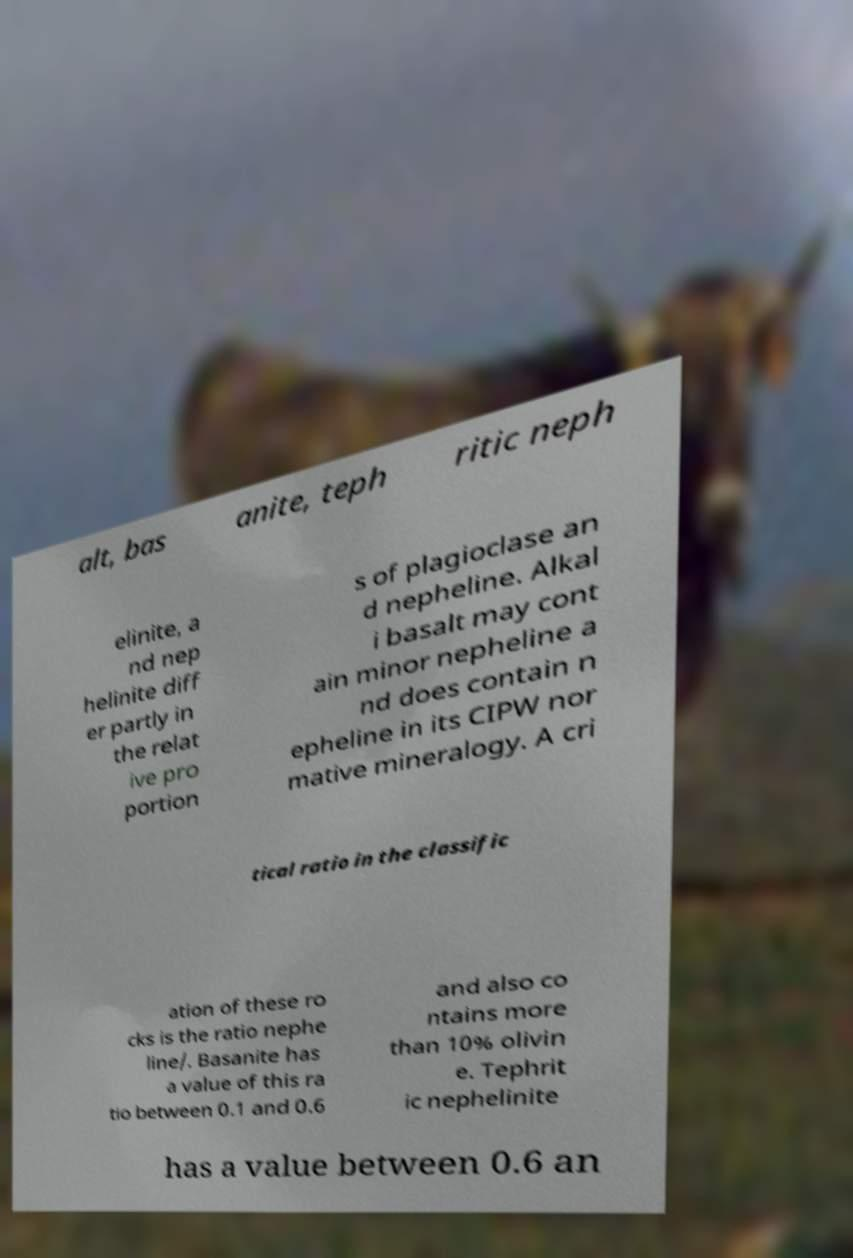What messages or text are displayed in this image? I need them in a readable, typed format. alt, bas anite, teph ritic neph elinite, a nd nep helinite diff er partly in the relat ive pro portion s of plagioclase an d nepheline. Alkal i basalt may cont ain minor nepheline a nd does contain n epheline in its CIPW nor mative mineralogy. A cri tical ratio in the classific ation of these ro cks is the ratio nephe line/. Basanite has a value of this ra tio between 0.1 and 0.6 and also co ntains more than 10% olivin e. Tephrit ic nephelinite has a value between 0.6 an 